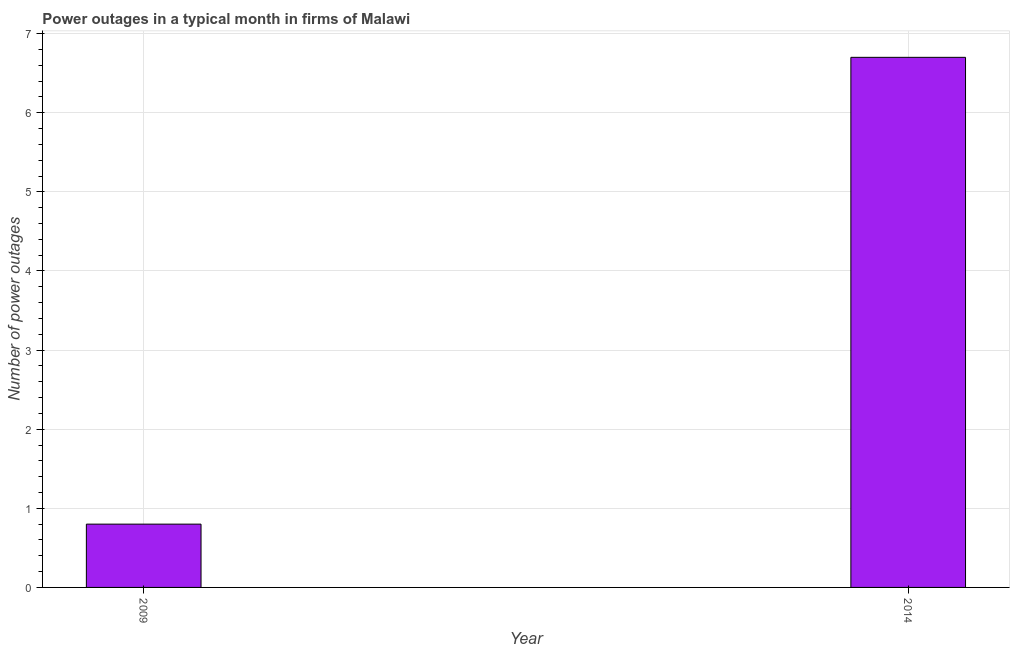Does the graph contain any zero values?
Offer a very short reply. No. What is the title of the graph?
Your answer should be compact. Power outages in a typical month in firms of Malawi. What is the label or title of the X-axis?
Ensure brevity in your answer.  Year. What is the label or title of the Y-axis?
Make the answer very short. Number of power outages. What is the average number of power outages per year?
Your response must be concise. 3.75. What is the median number of power outages?
Keep it short and to the point. 3.75. What is the ratio of the number of power outages in 2009 to that in 2014?
Keep it short and to the point. 0.12. Is the number of power outages in 2009 less than that in 2014?
Provide a short and direct response. Yes. In how many years, is the number of power outages greater than the average number of power outages taken over all years?
Keep it short and to the point. 1. Are all the bars in the graph horizontal?
Give a very brief answer. No. How many years are there in the graph?
Provide a short and direct response. 2. What is the Number of power outages of 2009?
Offer a very short reply. 0.8. What is the Number of power outages of 2014?
Your response must be concise. 6.7. What is the ratio of the Number of power outages in 2009 to that in 2014?
Your answer should be very brief. 0.12. 